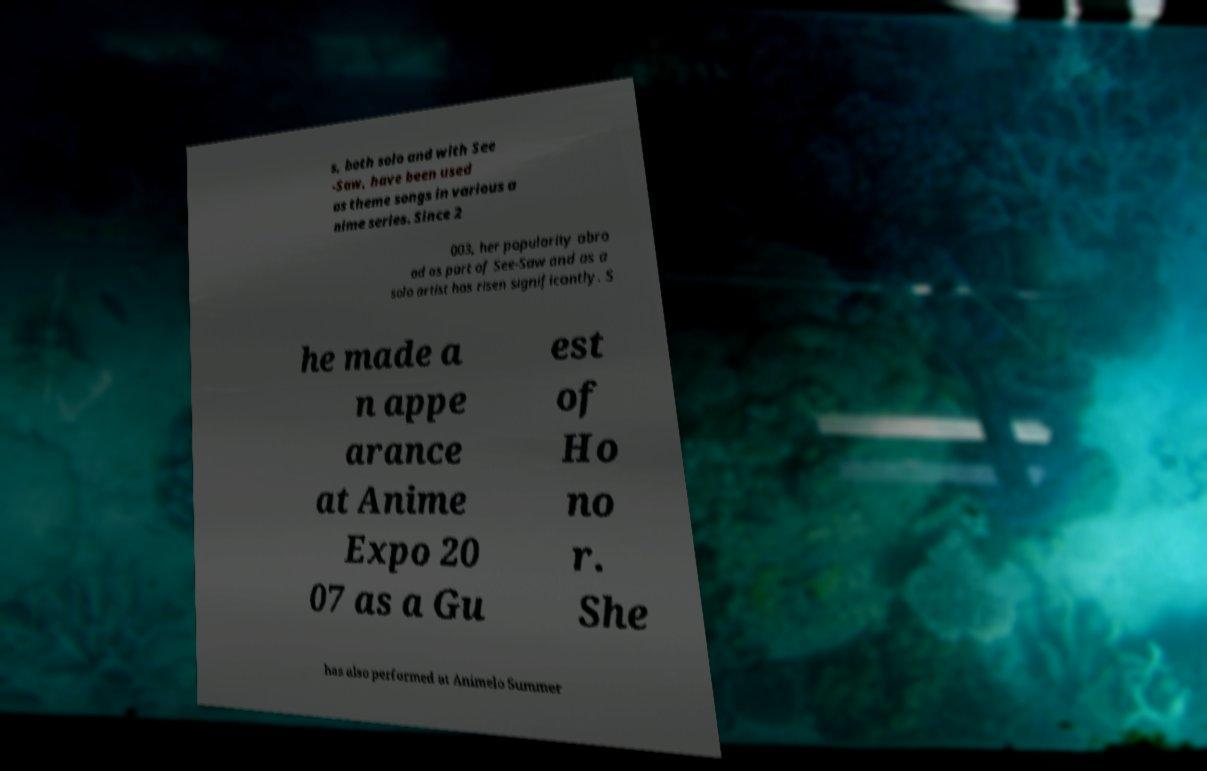Please identify and transcribe the text found in this image. s, both solo and with See -Saw, have been used as theme songs in various a nime series. Since 2 003, her popularity abro ad as part of See-Saw and as a solo artist has risen significantly. S he made a n appe arance at Anime Expo 20 07 as a Gu est of Ho no r. She has also performed at Animelo Summer 